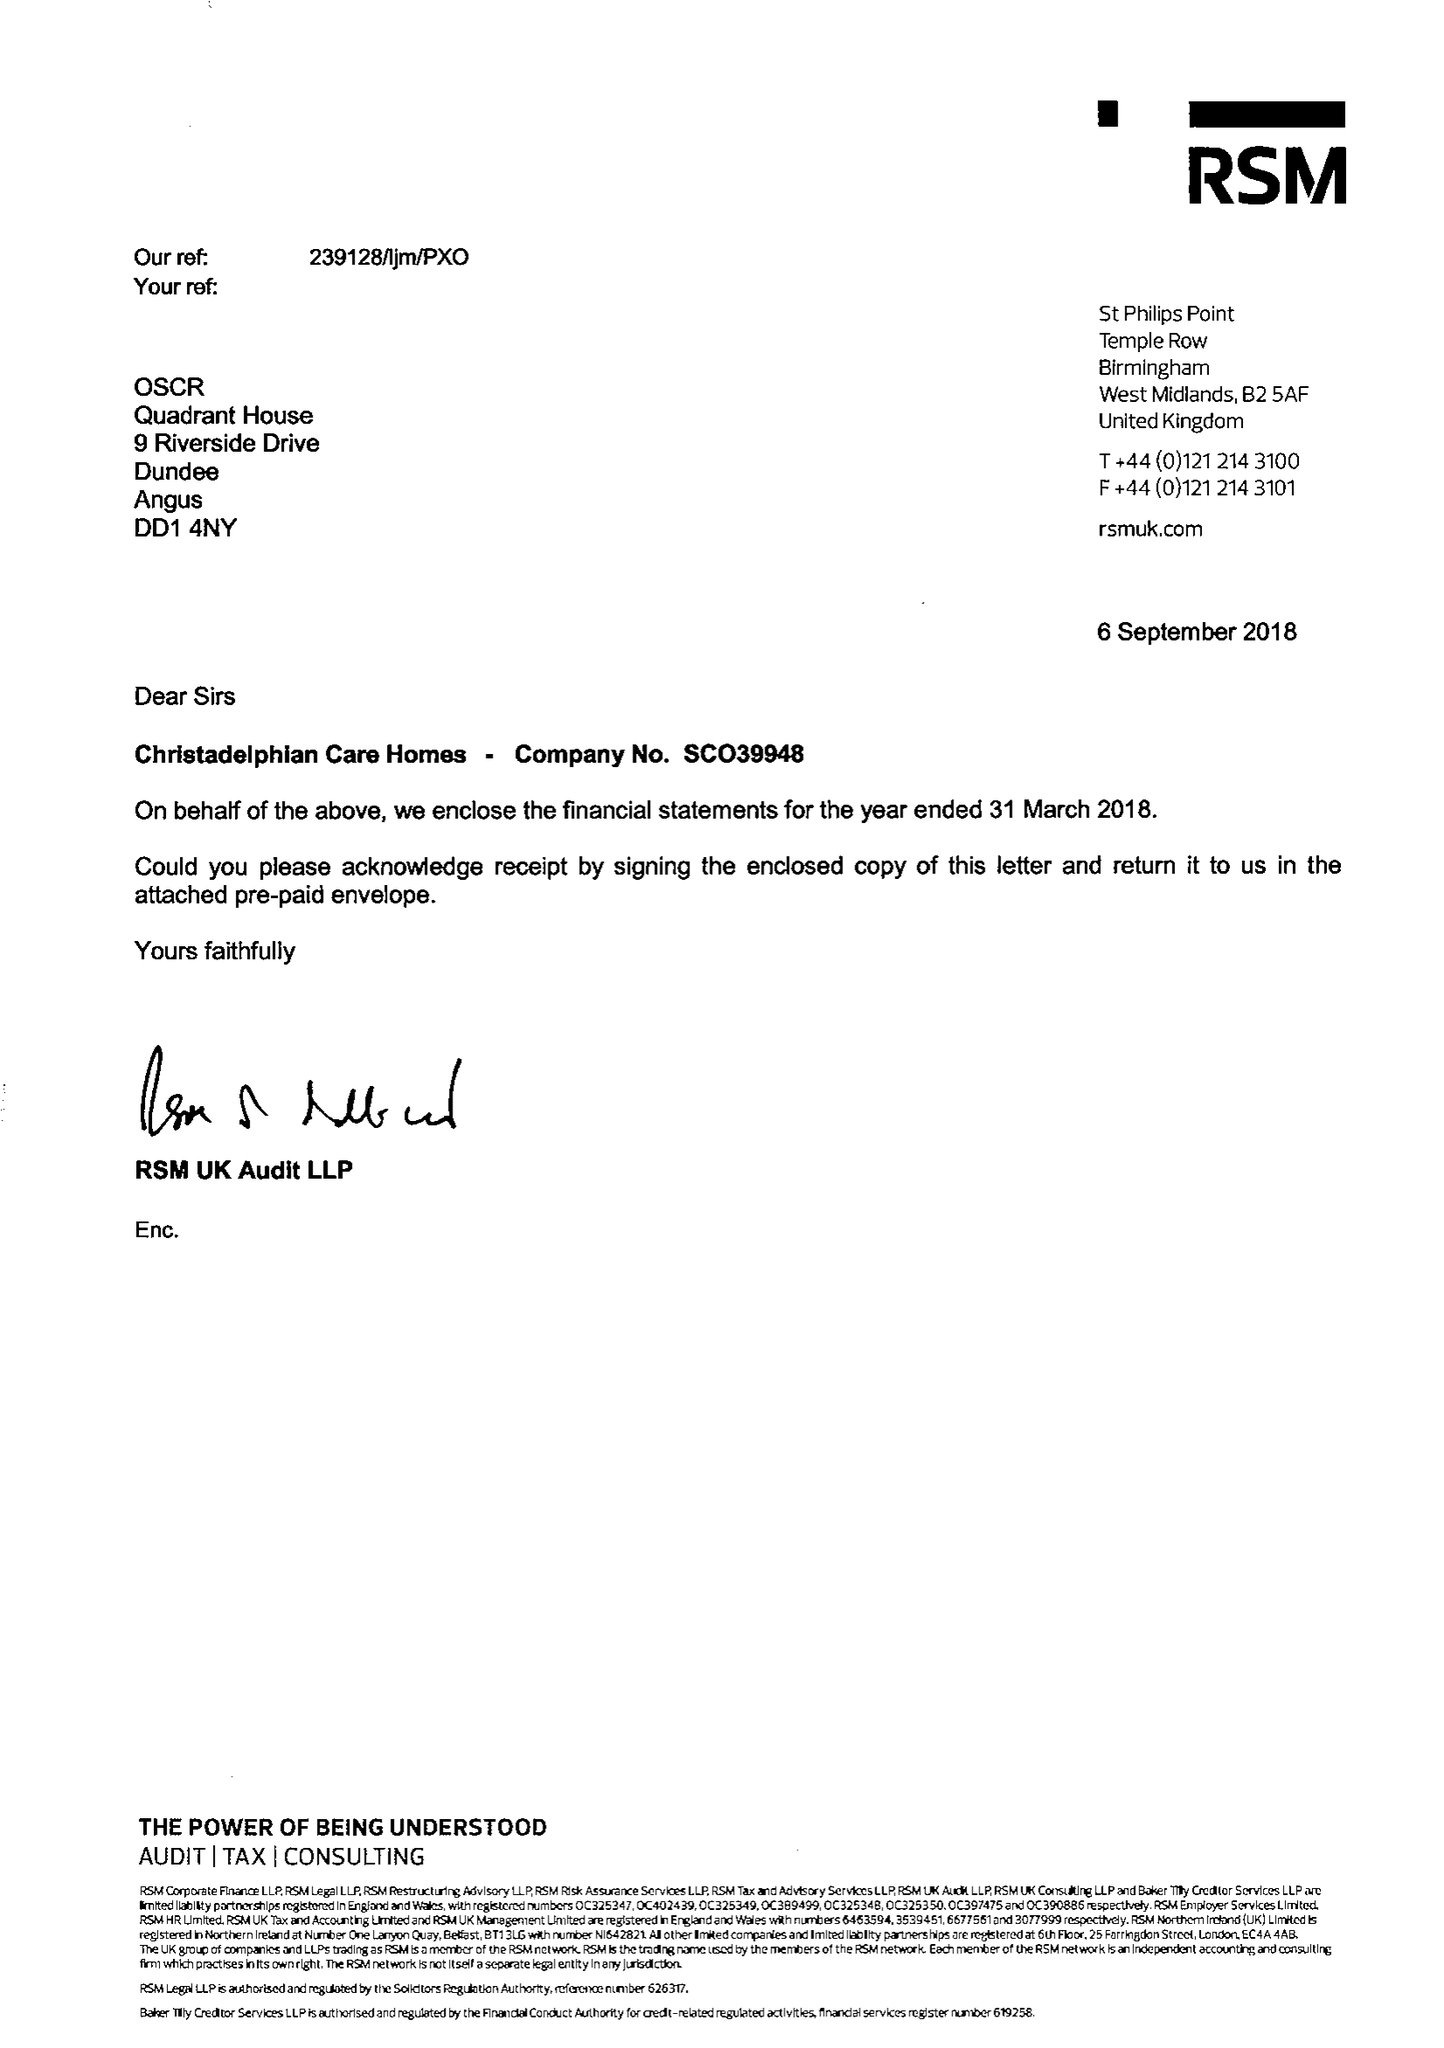What is the value for the charity_number?
Answer the question using a single word or phrase. 225874 